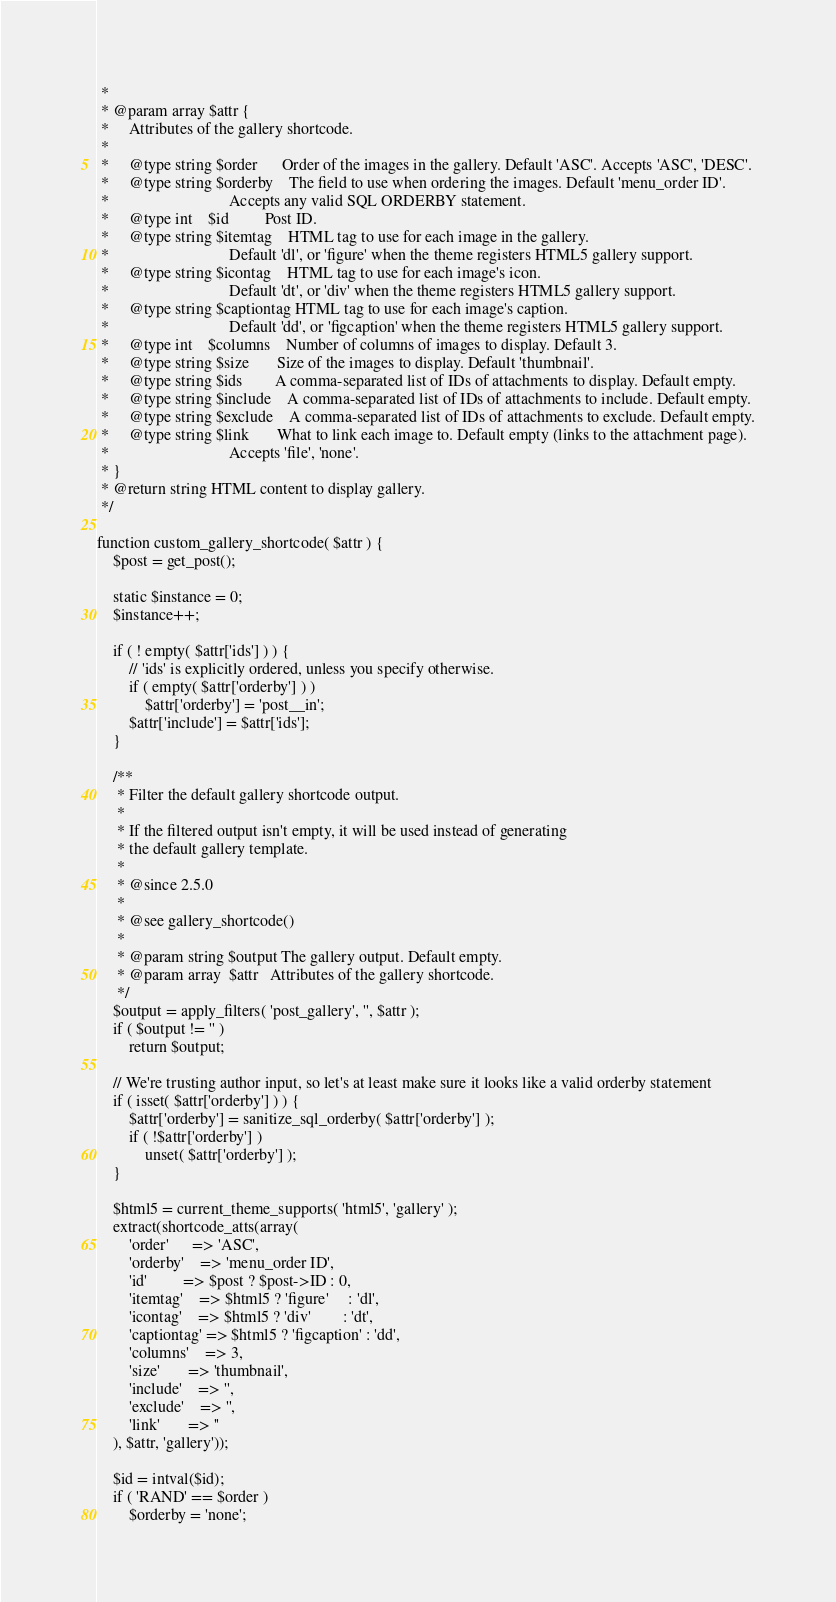Convert code to text. <code><loc_0><loc_0><loc_500><loc_500><_PHP_> *
 * @param array $attr {
 *     Attributes of the gallery shortcode.
 *
 *     @type string $order      Order of the images in the gallery. Default 'ASC'. Accepts 'ASC', 'DESC'.
 *     @type string $orderby    The field to use when ordering the images. Default 'menu_order ID'.
 *                              Accepts any valid SQL ORDERBY statement.
 *     @type int    $id         Post ID.
 *     @type string $itemtag    HTML tag to use for each image in the gallery.
 *                              Default 'dl', or 'figure' when the theme registers HTML5 gallery support.
 *     @type string $icontag    HTML tag to use for each image's icon.
 *                              Default 'dt', or 'div' when the theme registers HTML5 gallery support.
 *     @type string $captiontag HTML tag to use for each image's caption.
 *                              Default 'dd', or 'figcaption' when the theme registers HTML5 gallery support.
 *     @type int    $columns    Number of columns of images to display. Default 3.
 *     @type string $size       Size of the images to display. Default 'thumbnail'.
 *     @type string $ids        A comma-separated list of IDs of attachments to display. Default empty.
 *     @type string $include    A comma-separated list of IDs of attachments to include. Default empty.
 *     @type string $exclude    A comma-separated list of IDs of attachments to exclude. Default empty.
 *     @type string $link       What to link each image to. Default empty (links to the attachment page).
 *                              Accepts 'file', 'none'.
 * }
 * @return string HTML content to display gallery.
 */
 
function custom_gallery_shortcode( $attr ) {
	$post = get_post();

	static $instance = 0;
	$instance++;

	if ( ! empty( $attr['ids'] ) ) {
		// 'ids' is explicitly ordered, unless you specify otherwise.
		if ( empty( $attr['orderby'] ) )
			$attr['orderby'] = 'post__in';
		$attr['include'] = $attr['ids'];
	}

	/**
	 * Filter the default gallery shortcode output.
	 *
	 * If the filtered output isn't empty, it will be used instead of generating
	 * the default gallery template.
	 *
	 * @since 2.5.0
	 *
	 * @see gallery_shortcode()
	 *
	 * @param string $output The gallery output. Default empty.
	 * @param array  $attr   Attributes of the gallery shortcode.
	 */
	$output = apply_filters( 'post_gallery', '', $attr );
	if ( $output != '' )
		return $output;

	// We're trusting author input, so let's at least make sure it looks like a valid orderby statement
	if ( isset( $attr['orderby'] ) ) {
		$attr['orderby'] = sanitize_sql_orderby( $attr['orderby'] );
		if ( !$attr['orderby'] )
			unset( $attr['orderby'] );
	}

	$html5 = current_theme_supports( 'html5', 'gallery' );
	extract(shortcode_atts(array(
		'order'      => 'ASC',
		'orderby'    => 'menu_order ID',
		'id'         => $post ? $post->ID : 0,
		'itemtag'    => $html5 ? 'figure'     : 'dl',
		'icontag'    => $html5 ? 'div'        : 'dt',
		'captiontag' => $html5 ? 'figcaption' : 'dd',
		'columns'    => 3,
		'size'       => 'thumbnail',
		'include'    => '',
		'exclude'    => '',
		'link'       => ''
	), $attr, 'gallery'));

	$id = intval($id);
	if ( 'RAND' == $order )
		$orderby = 'none';
</code> 